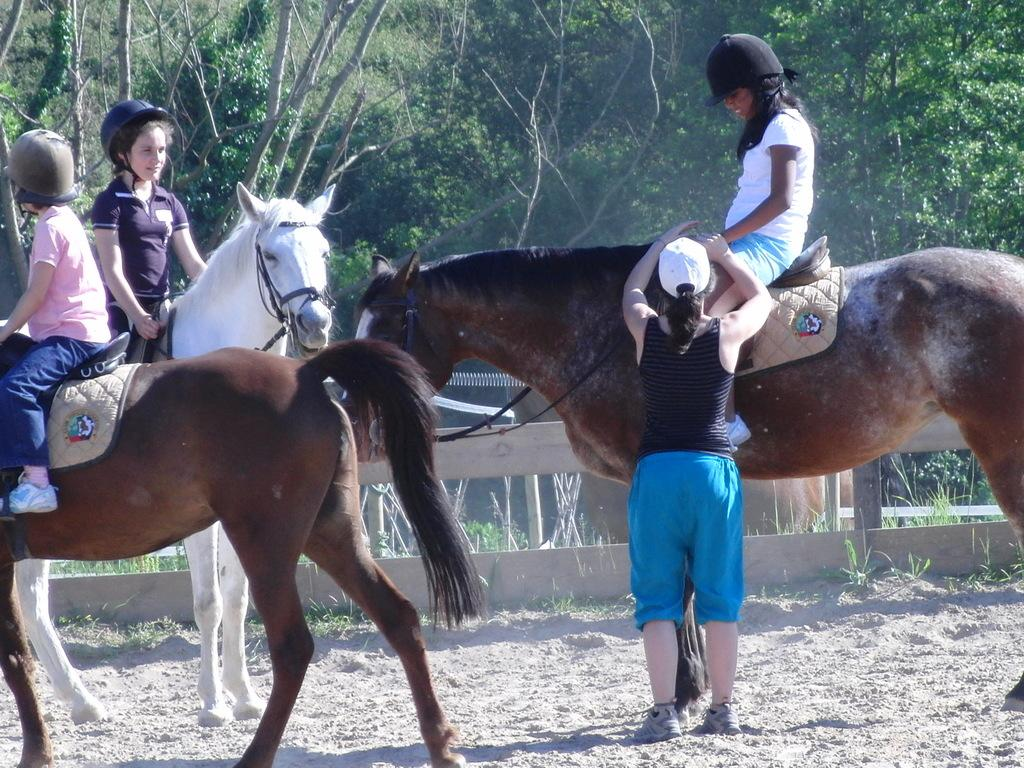How many girls are in the image? There are three girls in the image. What are the girls doing in the image? The girls are riding horses. Is there anyone else in the image besides the girls? Yes, there is a woman standing in the image. What can be seen in the background of the image? Trees are visible around the scene. What type of flesh can be seen on the horses in the image? There is no flesh visible on the horses in the image; they are covered by their fur and saddles. 